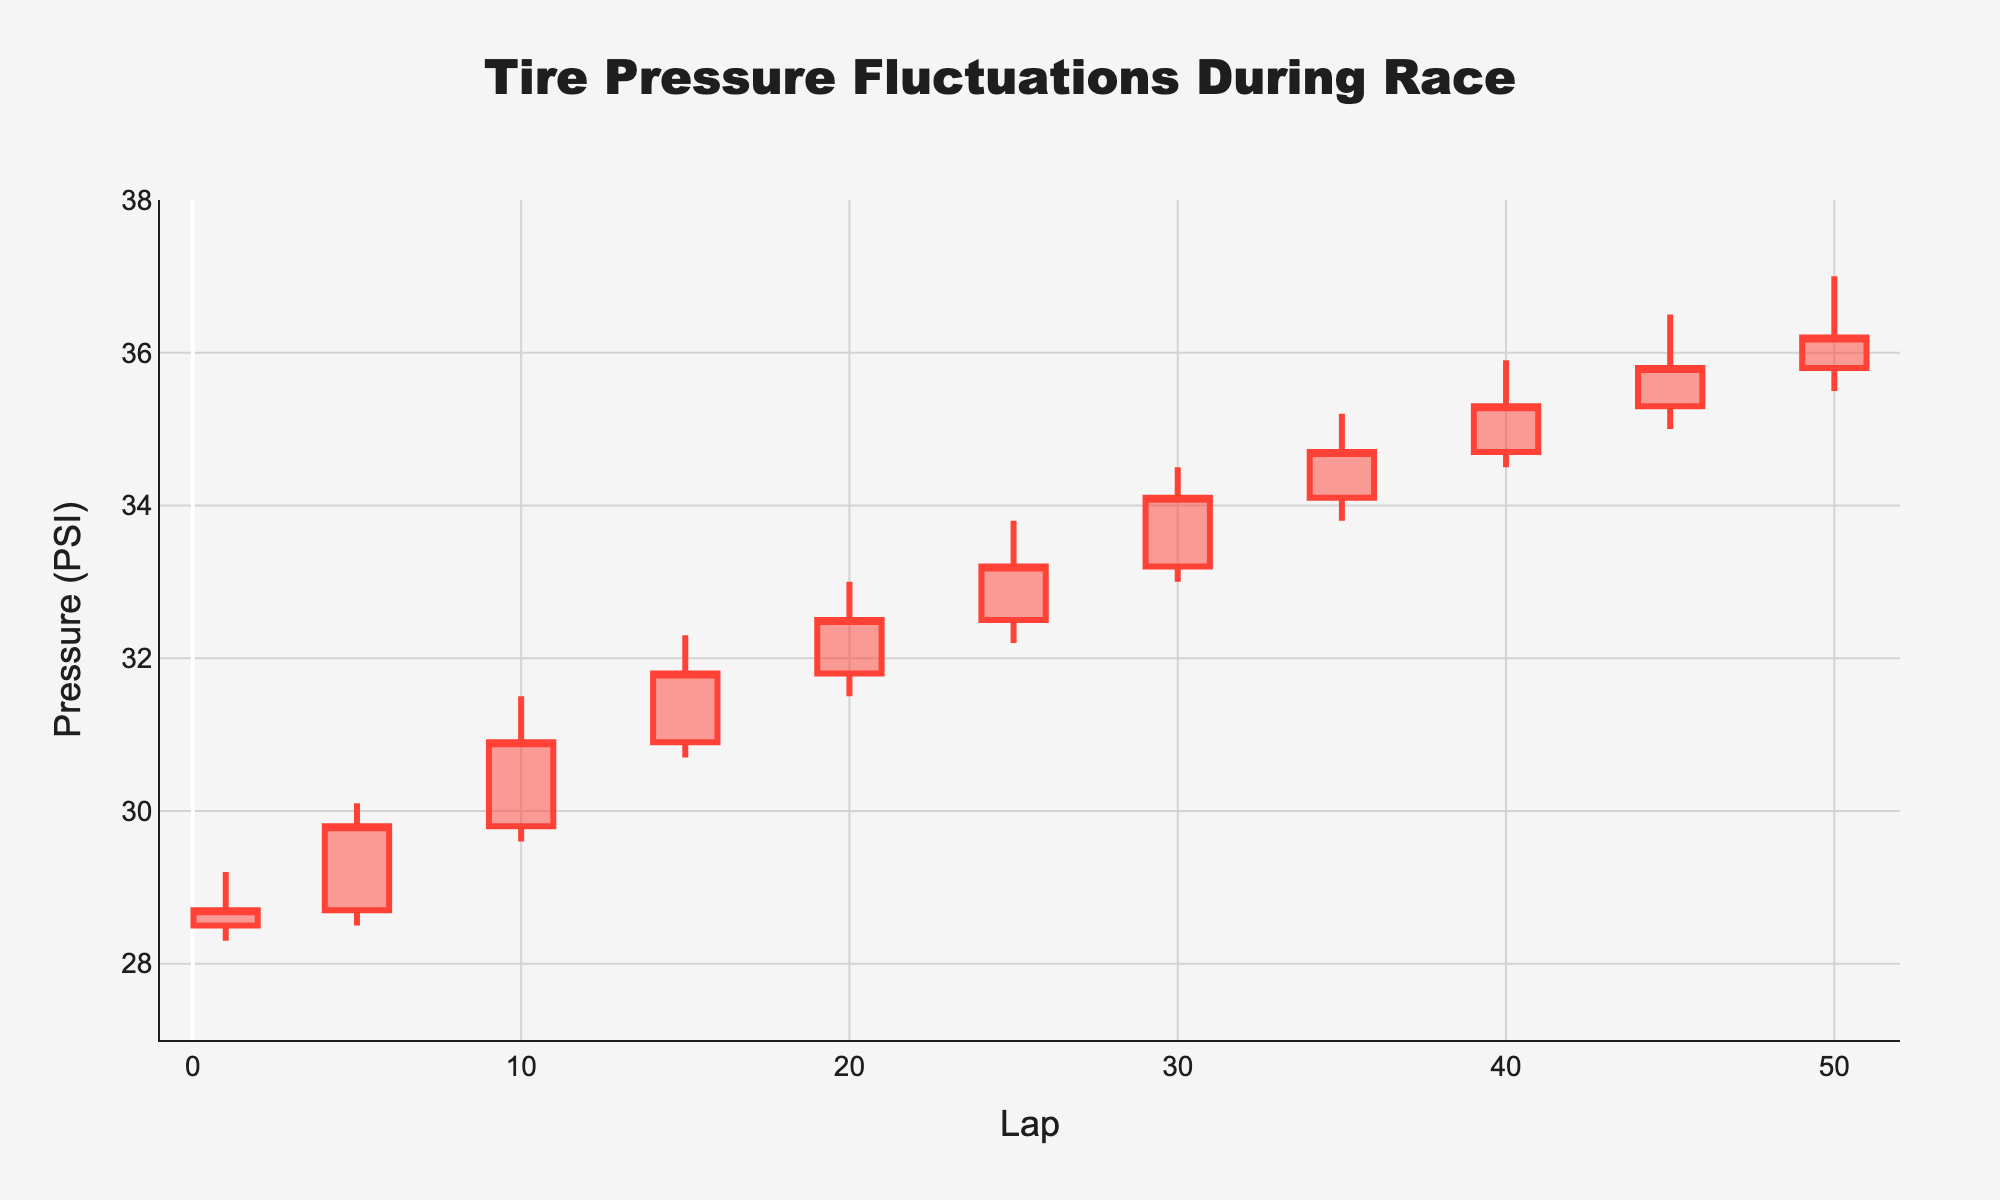What's the title of the chart? The title is displayed at the top of the chart in larger and bold text, making it easy to identify.
Answer: Tire Pressure Fluctuations During Race What is the highest tire pressure and on which lap does it occur? The highest tire pressure is indicated by the tallest candlestick's upper shadow or wick, which peaks at lap 50 with a high of 37.0 PSI.
Answer: 37.0 PSI on lap 50 During which lap did the tire pressure close at 31.8 PSI? The closing pressure for each lap is indicated by the rightmost tip of the candlestick's body. On lap 15, the candlestick's body closes at 31.8 PSI.
Answer: Lap 15 Which lap shows the highest increase in tire pressure from the opening to the closing value? Identify the lap with the widest candlestick body where the bottom represents the open and the top represents the close. Lap 5 has an increase from 28.7 PSI to 29.8 PSI, which is a change of 1.1 PSI.
Answer: Lap 5 What is the average closing pressure for the first 10 laps? Summing the closing pressures for the first 10 laps (28.7, 29.8, 30.9) and dividing by the number of these laps (3) gives (28.7 + 29.8 + 30.9) / 3 = 29.8 PSI.
Answer: 29.8 PSI Between which laps did the tire pressure reach a high of at least 35 PSI? By scanning the 'HighPSI' values, it is observed that laps 35 to 50 meet this criterion, as they all have highs of 35 PSI or more.
Answer: Laps 35 to 50 Between laps 25 and 35, what is the lowest tire pressure recorded and on which lap does it occur? Examining the 'LowPSI' values between laps 25 and 35, the lowest is 32.2 PSI, which occurs on lap 25.
Answer: Lap 25 with 32.2 PSI Which lap has the smallest range between high and low tire pressures? The range is calculated by subtracting 'LowPSI' from 'HighPSI' for each lap. The smallest range is on lap 1, with a range of 29.2 - 28.3 = 0.9 PSI.
Answer: Lap 1 What is the overall trend of the tire pressure throughout the race? Observing the candlestick bodies and wicks, there is a general increasing trend in tire pressures from the beginning to the end of the race.
Answer: Increasing On which lap did the tire pressure close higher than it opened? This can be identified by looking for candlesticks with the closing value higher than the opening value. The laps with an upward trend include laps 1, 5, 10, 15, 20, 25, 30, 35, 40, 45, and 50.
Answer: Laps 1, 5, 10, 15, 20, 25, 30, 35, 40, 45, and 50 